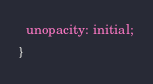<code> <loc_0><loc_0><loc_500><loc_500><_CSS_>  unopacity: initial;
}</code> 